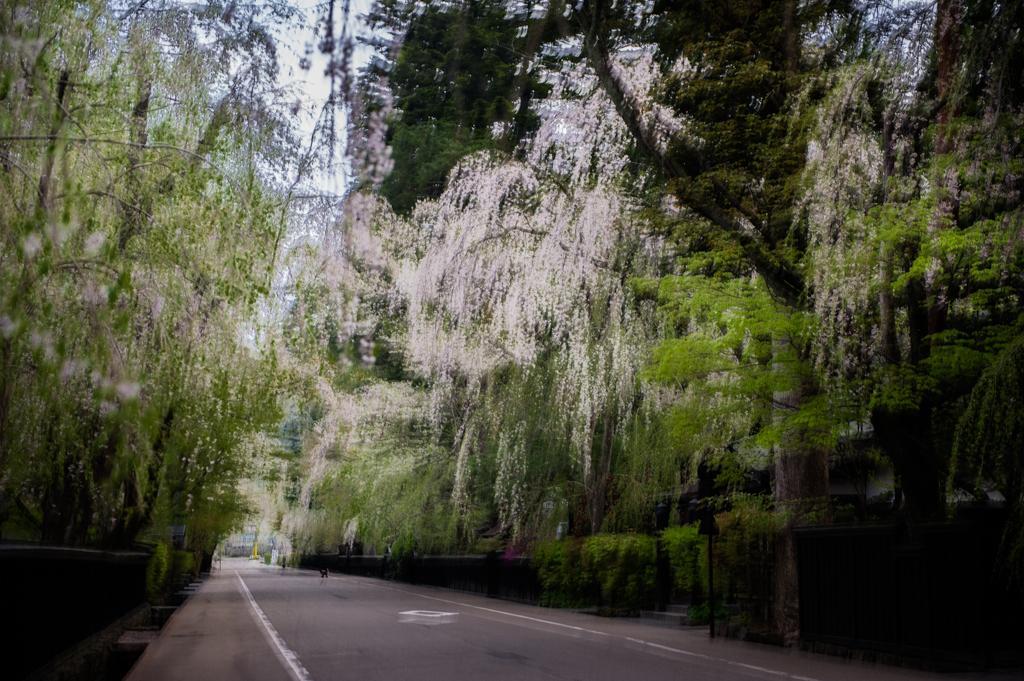Describe this image in one or two sentences. There is a road at the bottom side of the image and there are trees and sky in the background area. There is a pole on the right side. 